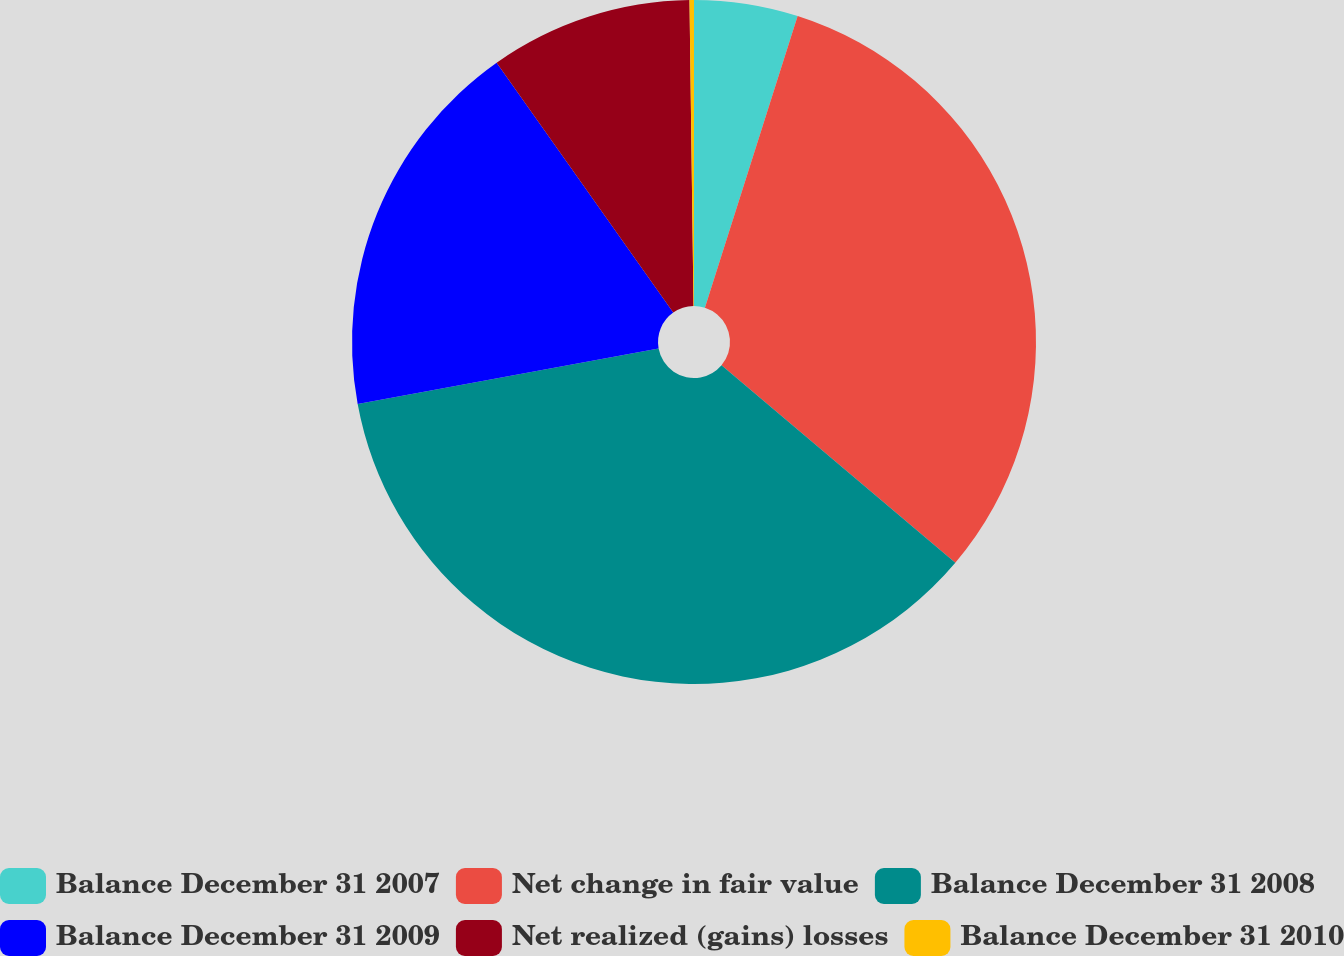Convert chart. <chart><loc_0><loc_0><loc_500><loc_500><pie_chart><fcel>Balance December 31 2007<fcel>Net change in fair value<fcel>Balance December 31 2008<fcel>Balance December 31 2009<fcel>Net realized (gains) losses<fcel>Balance December 31 2010<nl><fcel>4.9%<fcel>31.26%<fcel>35.94%<fcel>18.11%<fcel>9.58%<fcel>0.21%<nl></chart> 